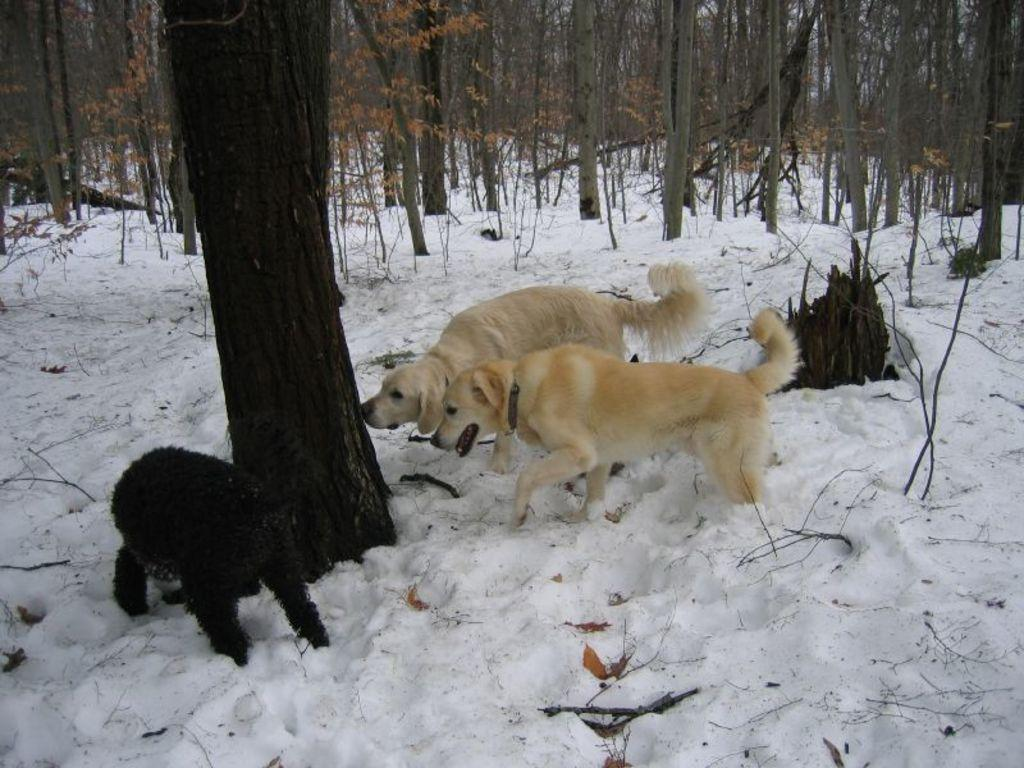What is the condition of the ground in the image? The ground is covered in snow. What can be seen on the snow-covered ground? There are trees on the snow-covered ground. How many dogs are in the image? There are two cream-colored dogs in the image. What is the color of the other animal in the image? There is a black-colored animal in the image. What is the income of the person who took the picture? There is no information about the person who took the picture, so their income cannot be determined. Can you tell me the memory capacity of the camera used to capture the image? The memory capacity of the camera used to capture the image is not mentioned in the facts provided. 